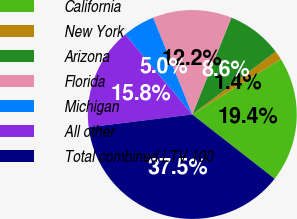<chart> <loc_0><loc_0><loc_500><loc_500><pie_chart><fcel>California<fcel>New York<fcel>Arizona<fcel>Florida<fcel>Michigan<fcel>All other<fcel>Total combined LTV 100<nl><fcel>19.44%<fcel>1.39%<fcel>8.61%<fcel>12.22%<fcel>5.0%<fcel>15.83%<fcel>37.5%<nl></chart> 